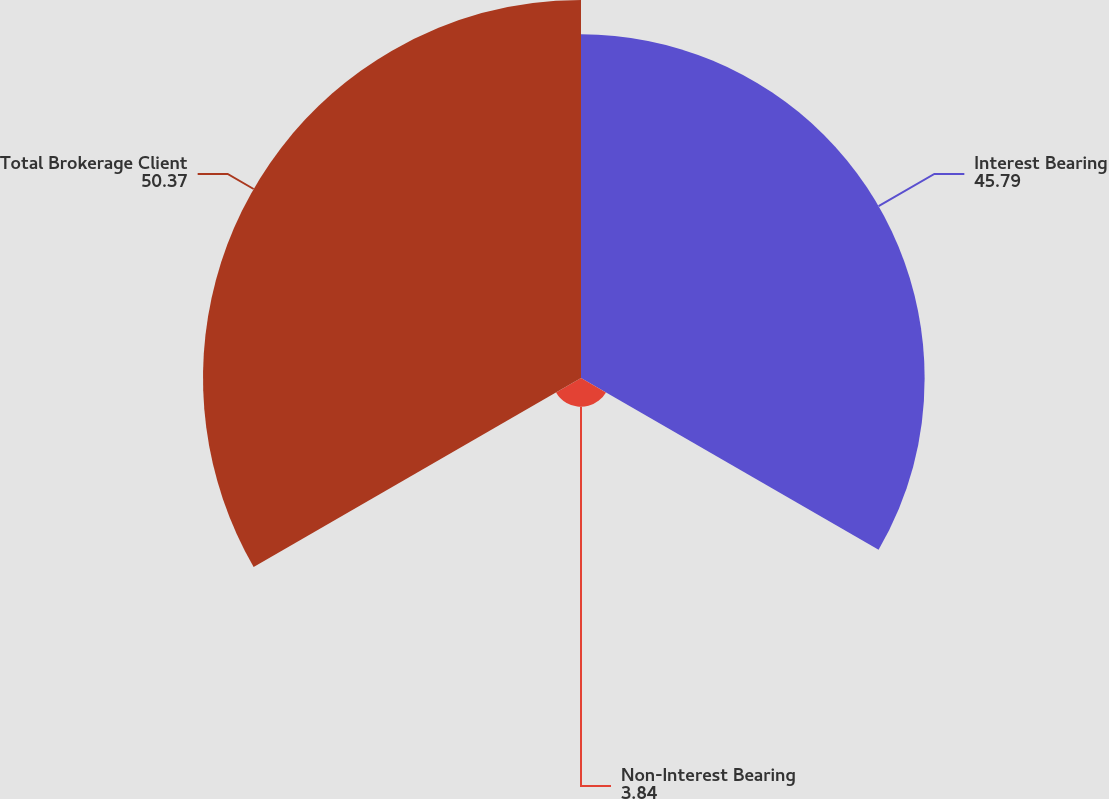<chart> <loc_0><loc_0><loc_500><loc_500><pie_chart><fcel>Interest Bearing<fcel>Non-Interest Bearing<fcel>Total Brokerage Client<nl><fcel>45.79%<fcel>3.84%<fcel>50.37%<nl></chart> 